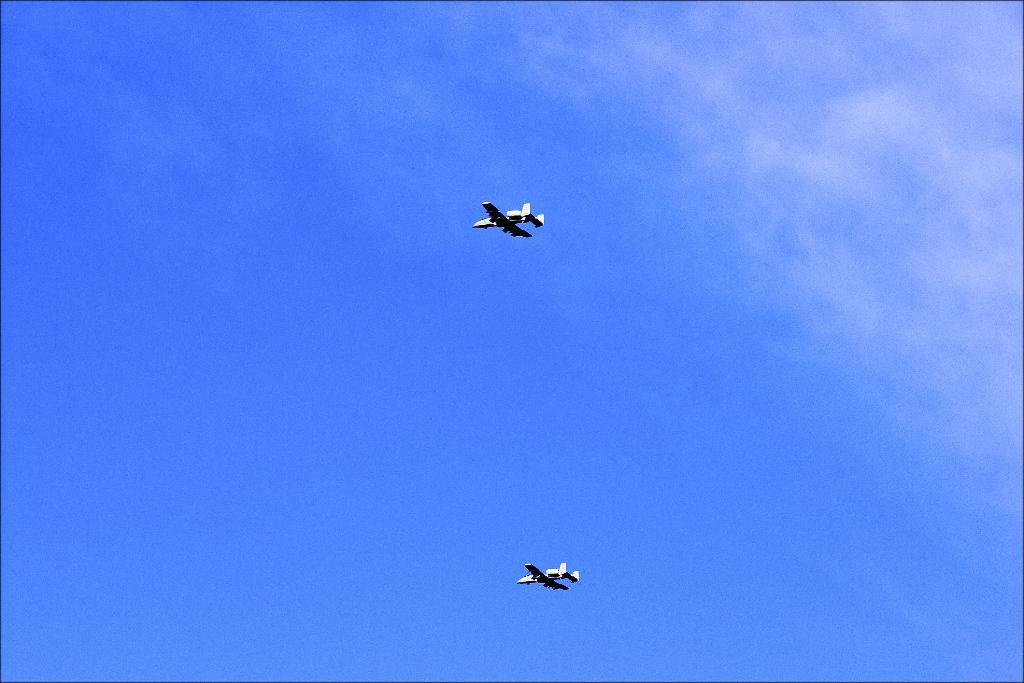How many airplanes can be seen in the image? There are two airplanes in the image. What are the airplanes doing in the image? The airplanes are flying in the air. What can be seen in the background of the image? The sky is visible in the background of the image. What type of soap is being used to clean the airplanes in the image? There is no soap or cleaning activity depicted in the image; the airplanes are simply flying in the air. 